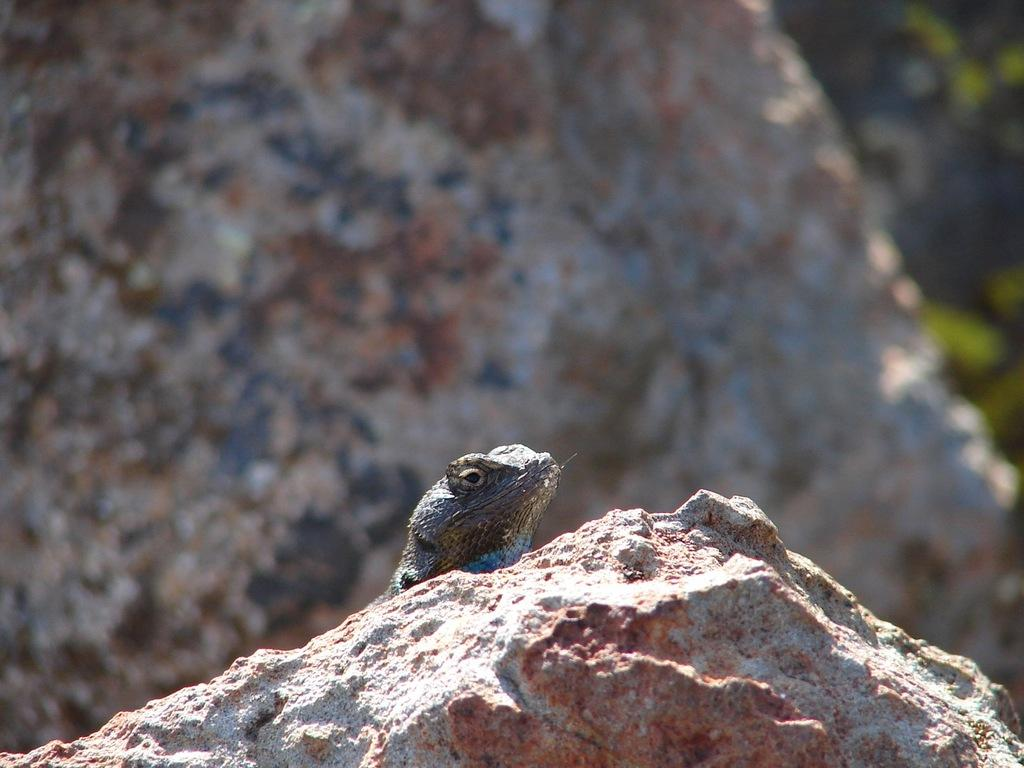What type of animal is in the image? There is a reptile in the image. Where is the reptile located? The reptile is on a rock. Can you describe the background of the image? There is another rock behind the reptile, and leaves of a plant are to the right of the reptile. What type of bucket is the tiger using to fight in the image? There is no bucket or tiger present in the image. 